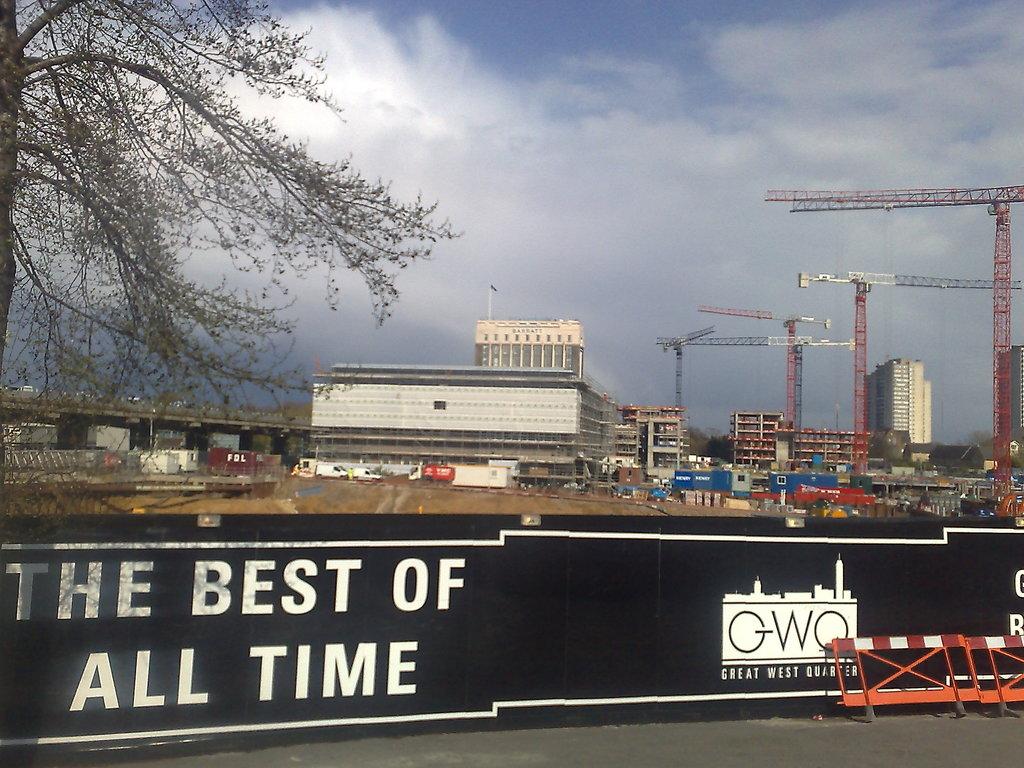What is great?
Your answer should be very brief. West quarter. The what of all time?
Ensure brevity in your answer.  Best. 